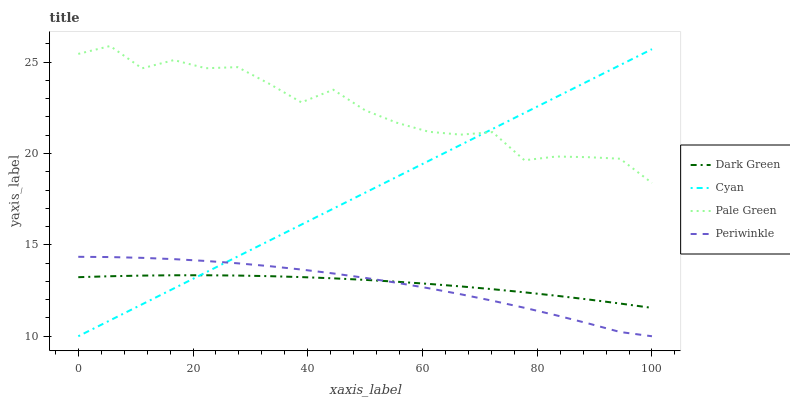Does Periwinkle have the minimum area under the curve?
Answer yes or no. Yes. Does Pale Green have the maximum area under the curve?
Answer yes or no. Yes. Does Pale Green have the minimum area under the curve?
Answer yes or no. No. Does Periwinkle have the maximum area under the curve?
Answer yes or no. No. Is Cyan the smoothest?
Answer yes or no. Yes. Is Pale Green the roughest?
Answer yes or no. Yes. Is Periwinkle the smoothest?
Answer yes or no. No. Is Periwinkle the roughest?
Answer yes or no. No. Does Pale Green have the lowest value?
Answer yes or no. No. Does Pale Green have the highest value?
Answer yes or no. Yes. Does Periwinkle have the highest value?
Answer yes or no. No. Is Dark Green less than Pale Green?
Answer yes or no. Yes. Is Pale Green greater than Periwinkle?
Answer yes or no. Yes. Does Dark Green intersect Periwinkle?
Answer yes or no. Yes. Is Dark Green less than Periwinkle?
Answer yes or no. No. Is Dark Green greater than Periwinkle?
Answer yes or no. No. Does Dark Green intersect Pale Green?
Answer yes or no. No. 